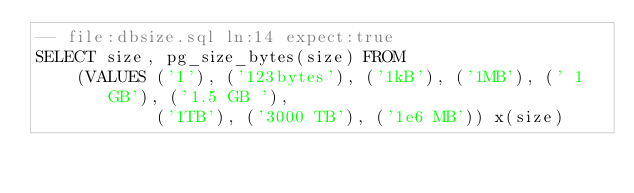Convert code to text. <code><loc_0><loc_0><loc_500><loc_500><_SQL_>-- file:dbsize.sql ln:14 expect:true
SELECT size, pg_size_bytes(size) FROM
    (VALUES ('1'), ('123bytes'), ('1kB'), ('1MB'), (' 1 GB'), ('1.5 GB '),
            ('1TB'), ('3000 TB'), ('1e6 MB')) x(size)
</code> 